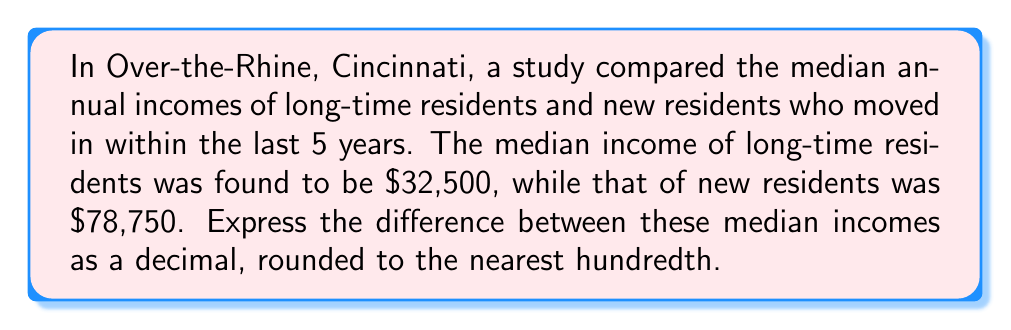Can you answer this question? To solve this problem, we'll follow these steps:

1) First, let's identify the two median incomes:
   Long-time residents: $32,500
   New residents: $78,750

2) To find the difference, we subtract the smaller value from the larger value:
   $78,750 - $32,500 = $46,250

3) Now, we need to express this difference as a decimal. To do this, we'll divide by 100 to move the decimal point two places to the left:
   $46,250 ÷ 100 = 462.50

4) The question asks for the answer rounded to the nearest hundredth, but 462.50 is already in that form, so no further rounding is necessary.

Therefore, the difference in median incomes expressed as a decimal is 462.50.
Answer: 462.50 